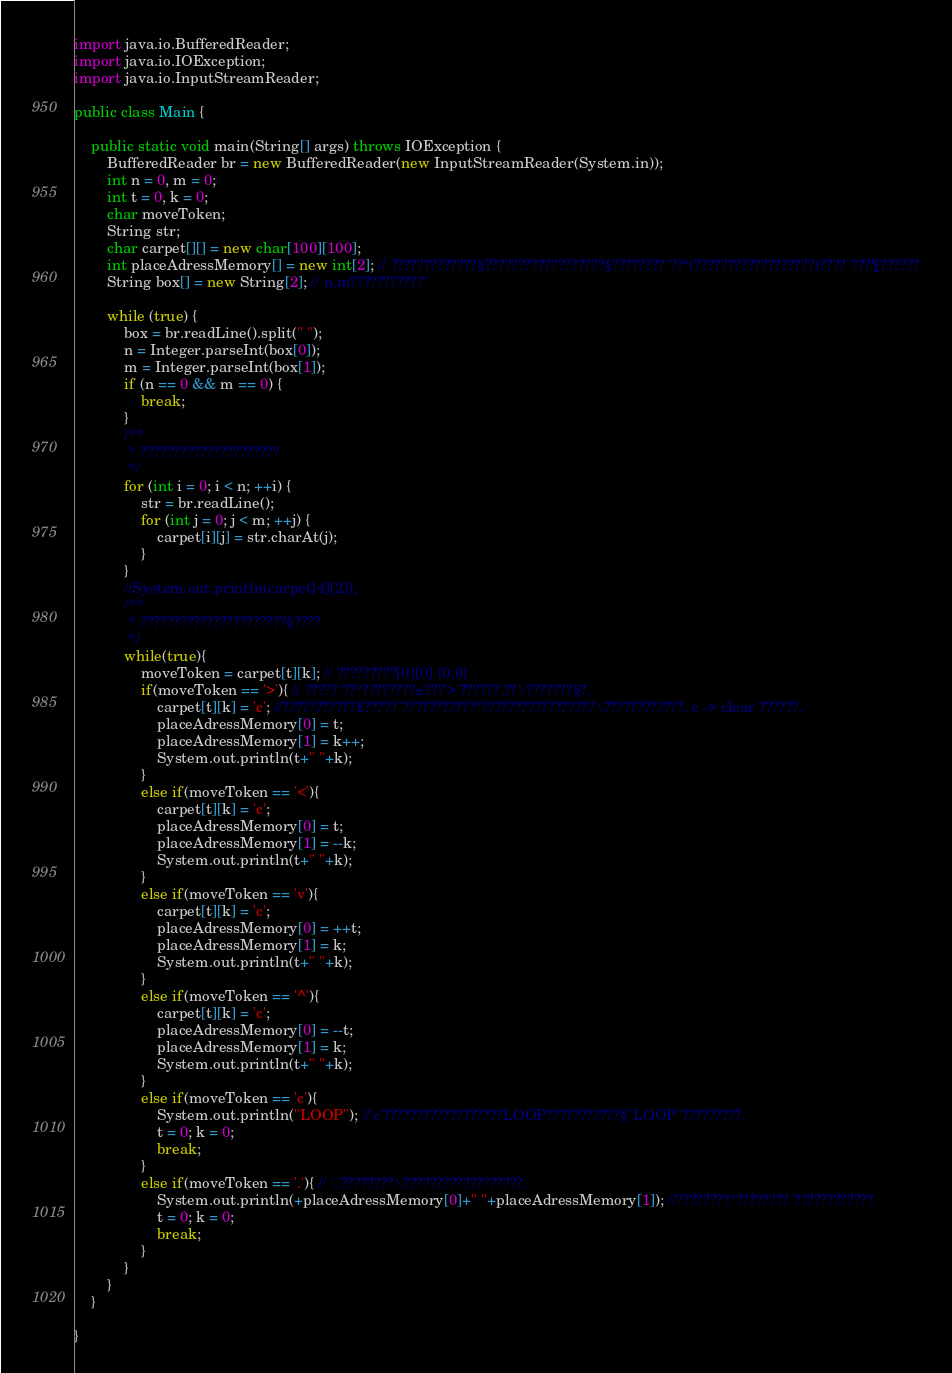<code> <loc_0><loc_0><loc_500><loc_500><_Java_>import java.io.BufferedReader;
import java.io.IOException;
import java.io.InputStreamReader;

public class Main {

	public static void main(String[] args) throws IOException {
		BufferedReader br = new BufferedReader(new InputStreamReader(System.in));
		int n = 0, m = 0;
		int t = 0, k = 0;
		char moveToken;
		String str;
		char carpet[][] = new char[100][100];
		int placeAdressMemory[] = new int[2]; // ?????????????§??????????????????§????????¨??°(??????????????????)????¨???¶??????
		String box[] = new String[2]; // n,m???????????¨

		while (true) {
			box = br.readLine().split(" ");
			n = Integer.parseInt(box[0]);
			m = Integer.parseInt(box[1]);
			if (n == 0 && m == 0) {
				break;
			}
			/**
			 * ?????????????????????
			 */
			for (int i = 0; i < n; ++i) {
				str = br.readLine();
				for (int j = 0; j < m; ++j) {
					carpet[i][j] = str.charAt(j);
				}
			}
			//System.out.println(carpet[4][2]);
			/**
			 * ??????????????????????§????
			 */
			while(true){
				moveToken = carpet[t][k]; // ?????????[0][0] {0,0}
				if(moveToken == '>'){ // ?????¨??°????????±???'>'??????.??\???????§?.
					carpet[t][k] = 'c'; //???????????£?????´???????????°?????????????????\????????????, c -> clear ??????.
					placeAdressMemory[0] = t;
					placeAdressMemory[1] = k++;
					System.out.println(t+" "+k);
				}
				else if(moveToken == '<'){
					carpet[t][k] = 'c';
					placeAdressMemory[0] = t;
					placeAdressMemory[1] = --k;
					System.out.println(t+" "+k);
				}
				else if(moveToken == 'v'){
					carpet[t][k] = 'c';
					placeAdressMemory[0] = ++t;
					placeAdressMemory[1] = k;
					System.out.println(t+" "+k);
				}
				else if(moveToken == '^'){
					carpet[t][k] = 'c';
					placeAdressMemory[0] = --t;
					placeAdressMemory[1] = k;
					System.out.println(t+" "+k);
				}
				else if(moveToken == 'c'){
					System.out.println("LOOP"); //'c'??????????????????LOOP???????????§"LOOP"?????????.
					t = 0; k = 0;
					break;
				}
				else if(moveToken == '.'){ // '.'????????\??????????????????.
					System.out.println(+placeAdressMemory[0]+" "+placeAdressMemory[1]); //????????°????????´????????????
					t = 0; k = 0;
					break;
				}
			}
		}
	}

}</code> 